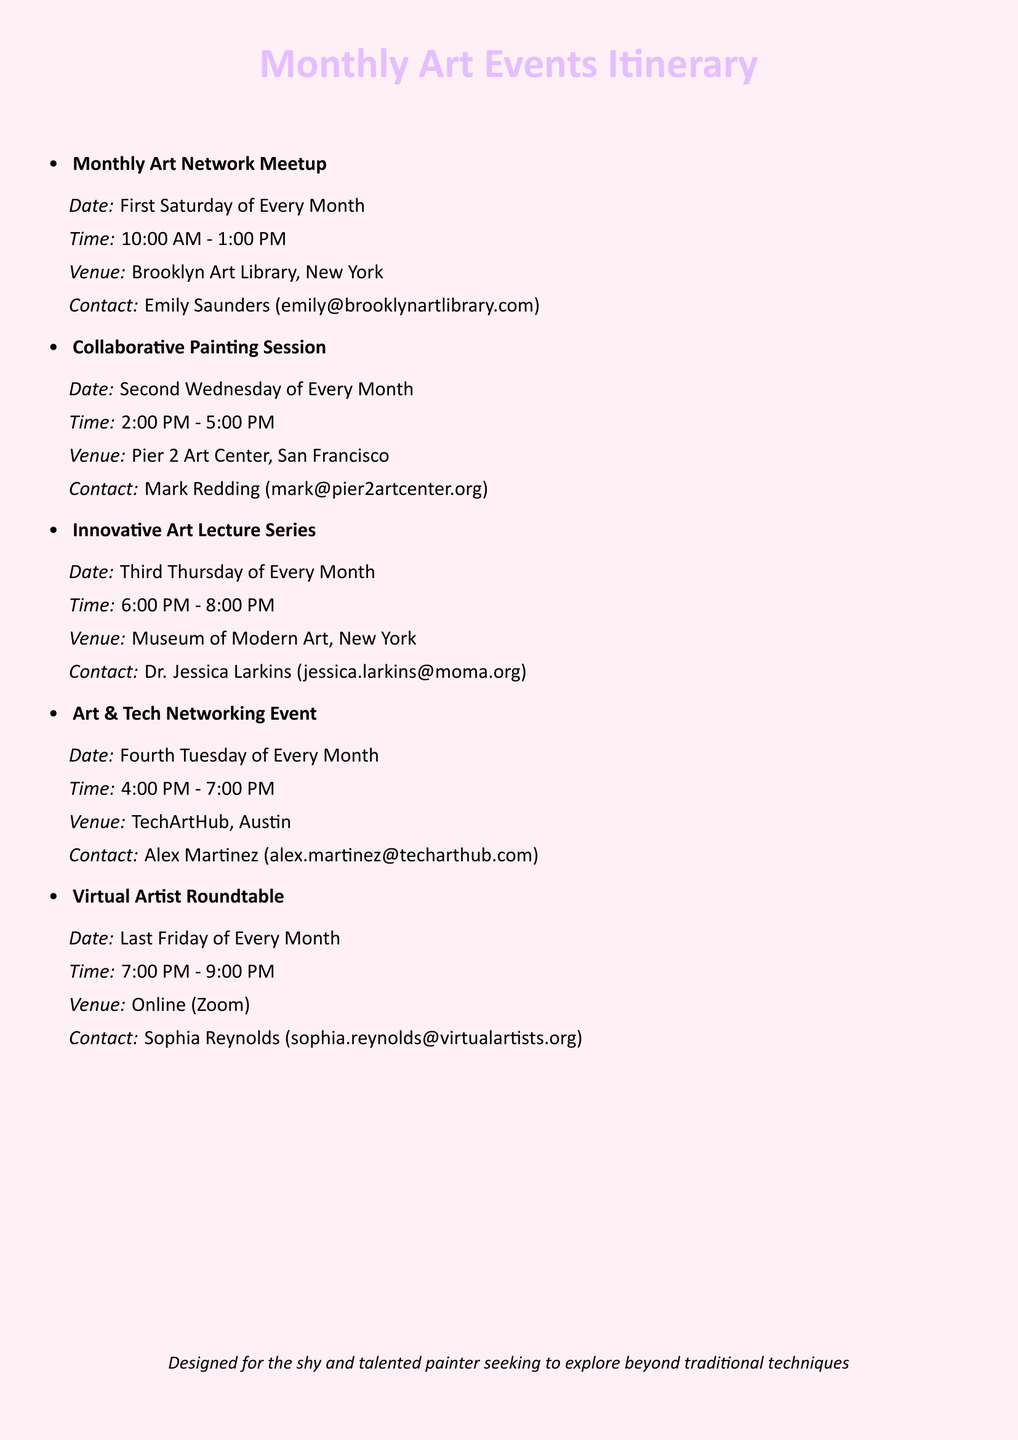What is the venue for the Collaborative Painting Session? The venue for the Collaborative Painting Session is mentioned in the document and is Pier 2 Art Center, San Francisco.
Answer: Pier 2 Art Center, San Francisco Who can be contacted for the Innovative Art Lecture Series? The contact information for the Innovative Art Lecture Series is Dr. Jessica Larkins's email provided in the document.
Answer: Dr. Jessica Larkins (jessica.larkins@moma.org) When does the Virtual Artist Roundtable take place? The document specifies that the Virtual Artist Roundtable is held on the last Friday of every month.
Answer: Last Friday of Every Month What is the time for the Art & Tech Networking Event? The document states the time for the Art & Tech Networking Event, which is a specific time range.
Answer: 4:00 PM - 7:00 PM How many events occur each month according to the itinerary? The document lists five unique events which occur monthly according to the itinerary.
Answer: Five 